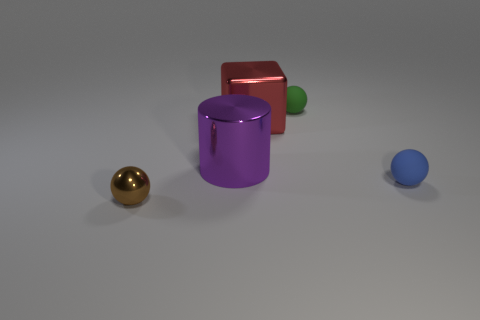Can you describe the positioning of the objects in this image from left to right? From left to right, there's a golden sphere, a purple cylinder, and slightly behind it, a green sphere. Directly behind the purple cylinder is a red cube, and to the far right, there's a small blue sphere. 